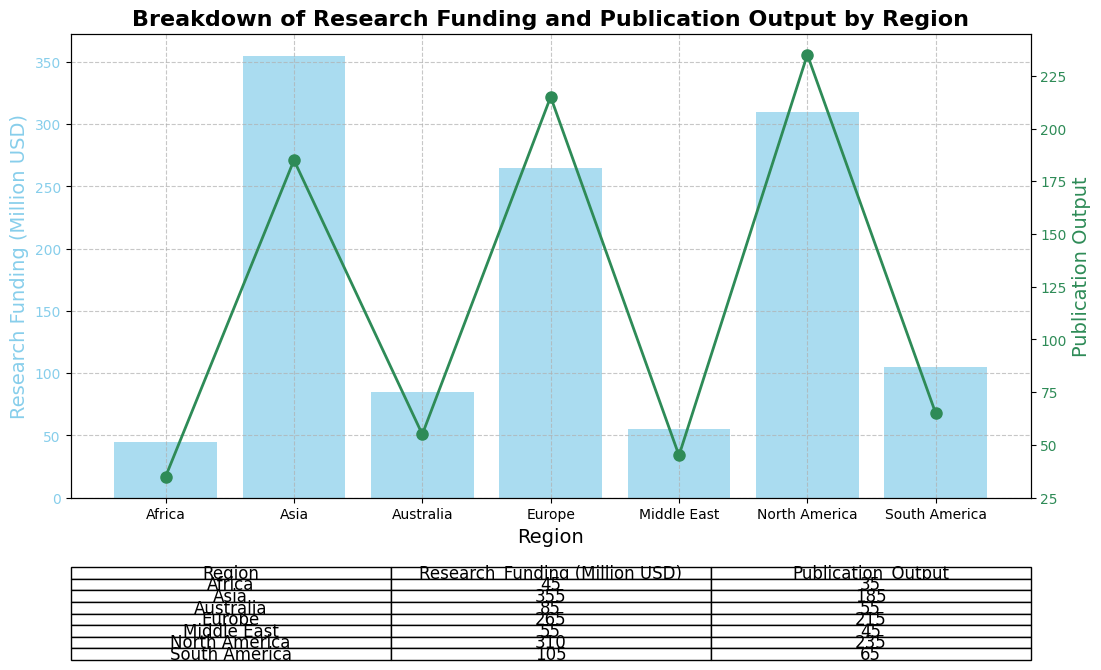What is the total research funding allocated to North America? To calculate the total research funding for North America, we sum up the funding for North America from both rows: 150 + 160 = 310 million USD.
Answer: 310 million USD Which region has the highest publication output? By looking at the publication output values for all regions, we can see that North America's output of 235 has the highest.
Answer: North America How does Asia’s research funding compare to Europe's? The total research funding for Asia is 180 + 175 = 355 million USD, while Europe has 130 + 135 = 265 million USD. Asia's funding is higher.
Answer: Asia has higher research funding than Europe What is the relationship between the research funding and publication output in South America? South America's total research funding is 50+55 = 105 million USD, and its publication output is 30+35 = 65. A proportional relationship indicates that increased funding correlates with increased output.
Answer: Proportional relationship What is the average research funding allocated across all regions? Sum all the research funding from each region: 310 (North America) + 265 (Europe) + 355 (Asia) + 105 (South America) + 45 (Africa) + 85 (Australia) + 55 (Middle East)= 1220 million USD. With 7 regions, the average is 1220 / 7 ≈ 174.29 million USD.
Answer: ~174.29 million USD What is the difference in publication output between Africa and Australia? Africa has a total of 35 publications, and Australia has 55. The difference is 55 - 35 = 20.
Answer: 20 Which region has the lowest research funding and what is it? By comparing the total research funding for each region, Africa has the lowest with 20 + 25 = 45 million USD.
Answer: Africa, 45 million USD If North America’s research funding increases by 10%, what would the new funding amount be? North America's current total funding is 310 million USD. Increasing by 10%: 310 * 1.10 = 341 million USD.
Answer: 341 million USD 